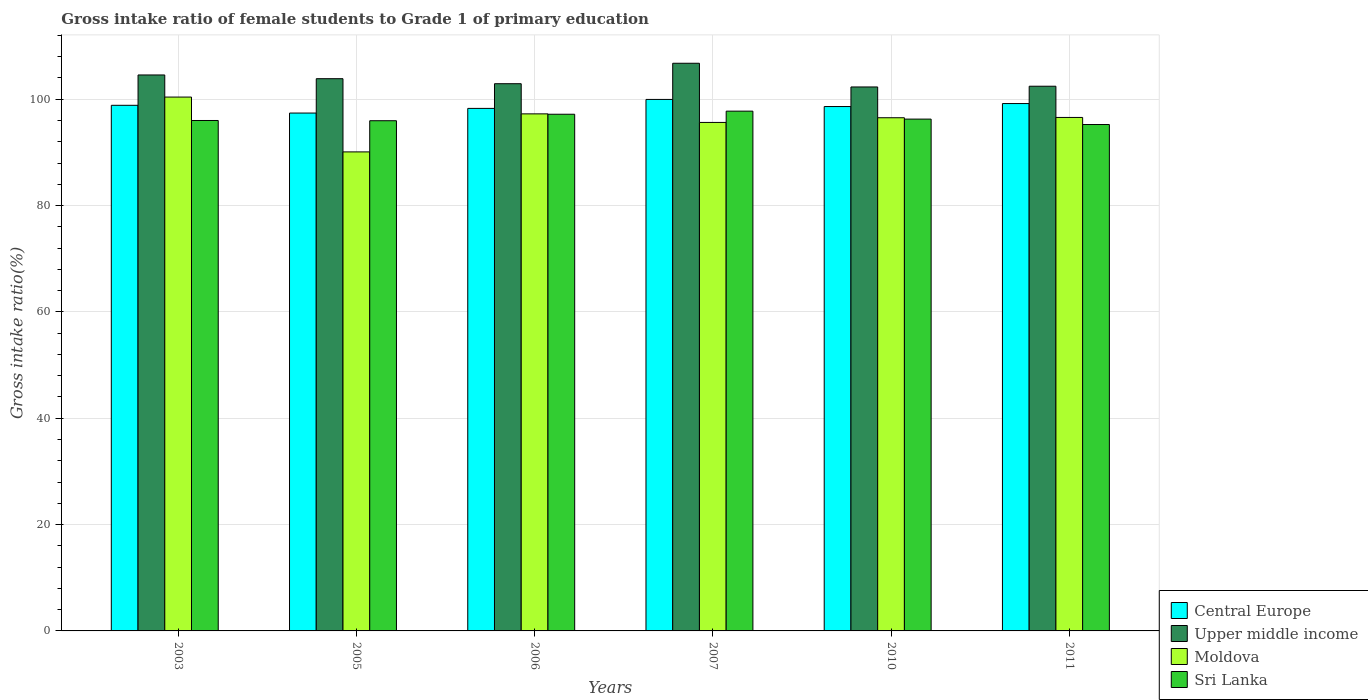Are the number of bars per tick equal to the number of legend labels?
Ensure brevity in your answer.  Yes. Are the number of bars on each tick of the X-axis equal?
Your answer should be very brief. Yes. How many bars are there on the 3rd tick from the left?
Give a very brief answer. 4. What is the label of the 2nd group of bars from the left?
Provide a succinct answer. 2005. What is the gross intake ratio in Sri Lanka in 2007?
Offer a very short reply. 97.76. Across all years, what is the maximum gross intake ratio in Central Europe?
Give a very brief answer. 99.97. Across all years, what is the minimum gross intake ratio in Upper middle income?
Offer a very short reply. 102.31. What is the total gross intake ratio in Sri Lanka in the graph?
Give a very brief answer. 578.43. What is the difference between the gross intake ratio in Upper middle income in 2005 and that in 2011?
Offer a terse response. 1.42. What is the difference between the gross intake ratio in Moldova in 2007 and the gross intake ratio in Upper middle income in 2005?
Make the answer very short. -8.22. What is the average gross intake ratio in Sri Lanka per year?
Give a very brief answer. 96.41. In the year 2007, what is the difference between the gross intake ratio in Upper middle income and gross intake ratio in Sri Lanka?
Keep it short and to the point. 9.01. In how many years, is the gross intake ratio in Moldova greater than 48 %?
Keep it short and to the point. 6. What is the ratio of the gross intake ratio in Moldova in 2005 to that in 2007?
Keep it short and to the point. 0.94. What is the difference between the highest and the second highest gross intake ratio in Upper middle income?
Offer a terse response. 2.2. What is the difference between the highest and the lowest gross intake ratio in Central Europe?
Give a very brief answer. 2.56. In how many years, is the gross intake ratio in Moldova greater than the average gross intake ratio in Moldova taken over all years?
Keep it short and to the point. 4. Is the sum of the gross intake ratio in Sri Lanka in 2005 and 2007 greater than the maximum gross intake ratio in Moldova across all years?
Keep it short and to the point. Yes. What does the 3rd bar from the left in 2006 represents?
Your answer should be compact. Moldova. What does the 1st bar from the right in 2007 represents?
Ensure brevity in your answer.  Sri Lanka. Is it the case that in every year, the sum of the gross intake ratio in Central Europe and gross intake ratio in Upper middle income is greater than the gross intake ratio in Sri Lanka?
Your response must be concise. Yes. How many bars are there?
Keep it short and to the point. 24. What is the difference between two consecutive major ticks on the Y-axis?
Give a very brief answer. 20. Where does the legend appear in the graph?
Provide a succinct answer. Bottom right. How many legend labels are there?
Your response must be concise. 4. What is the title of the graph?
Ensure brevity in your answer.  Gross intake ratio of female students to Grade 1 of primary education. Does "Sint Maarten (Dutch part)" appear as one of the legend labels in the graph?
Make the answer very short. No. What is the label or title of the Y-axis?
Provide a short and direct response. Gross intake ratio(%). What is the Gross intake ratio(%) in Central Europe in 2003?
Ensure brevity in your answer.  98.86. What is the Gross intake ratio(%) in Upper middle income in 2003?
Your answer should be compact. 104.57. What is the Gross intake ratio(%) of Moldova in 2003?
Ensure brevity in your answer.  100.41. What is the Gross intake ratio(%) in Sri Lanka in 2003?
Provide a succinct answer. 96.01. What is the Gross intake ratio(%) of Central Europe in 2005?
Your answer should be very brief. 97.4. What is the Gross intake ratio(%) in Upper middle income in 2005?
Your response must be concise. 103.87. What is the Gross intake ratio(%) in Moldova in 2005?
Ensure brevity in your answer.  90.1. What is the Gross intake ratio(%) of Sri Lanka in 2005?
Keep it short and to the point. 95.96. What is the Gross intake ratio(%) of Central Europe in 2006?
Provide a short and direct response. 98.28. What is the Gross intake ratio(%) in Upper middle income in 2006?
Your response must be concise. 102.93. What is the Gross intake ratio(%) in Moldova in 2006?
Offer a terse response. 97.25. What is the Gross intake ratio(%) in Sri Lanka in 2006?
Offer a very short reply. 97.18. What is the Gross intake ratio(%) of Central Europe in 2007?
Your answer should be compact. 99.97. What is the Gross intake ratio(%) in Upper middle income in 2007?
Give a very brief answer. 106.77. What is the Gross intake ratio(%) of Moldova in 2007?
Give a very brief answer. 95.64. What is the Gross intake ratio(%) of Sri Lanka in 2007?
Ensure brevity in your answer.  97.76. What is the Gross intake ratio(%) of Central Europe in 2010?
Give a very brief answer. 98.63. What is the Gross intake ratio(%) in Upper middle income in 2010?
Give a very brief answer. 102.31. What is the Gross intake ratio(%) in Moldova in 2010?
Your answer should be compact. 96.52. What is the Gross intake ratio(%) of Sri Lanka in 2010?
Keep it short and to the point. 96.27. What is the Gross intake ratio(%) in Central Europe in 2011?
Provide a short and direct response. 99.19. What is the Gross intake ratio(%) of Upper middle income in 2011?
Your answer should be compact. 102.45. What is the Gross intake ratio(%) in Moldova in 2011?
Give a very brief answer. 96.58. What is the Gross intake ratio(%) of Sri Lanka in 2011?
Offer a terse response. 95.25. Across all years, what is the maximum Gross intake ratio(%) of Central Europe?
Ensure brevity in your answer.  99.97. Across all years, what is the maximum Gross intake ratio(%) in Upper middle income?
Make the answer very short. 106.77. Across all years, what is the maximum Gross intake ratio(%) in Moldova?
Offer a very short reply. 100.41. Across all years, what is the maximum Gross intake ratio(%) in Sri Lanka?
Provide a succinct answer. 97.76. Across all years, what is the minimum Gross intake ratio(%) in Central Europe?
Offer a terse response. 97.4. Across all years, what is the minimum Gross intake ratio(%) in Upper middle income?
Offer a terse response. 102.31. Across all years, what is the minimum Gross intake ratio(%) of Moldova?
Your answer should be very brief. 90.1. Across all years, what is the minimum Gross intake ratio(%) in Sri Lanka?
Provide a succinct answer. 95.25. What is the total Gross intake ratio(%) of Central Europe in the graph?
Give a very brief answer. 592.34. What is the total Gross intake ratio(%) of Upper middle income in the graph?
Ensure brevity in your answer.  622.9. What is the total Gross intake ratio(%) in Moldova in the graph?
Your answer should be very brief. 576.51. What is the total Gross intake ratio(%) of Sri Lanka in the graph?
Your answer should be compact. 578.43. What is the difference between the Gross intake ratio(%) of Central Europe in 2003 and that in 2005?
Give a very brief answer. 1.46. What is the difference between the Gross intake ratio(%) of Upper middle income in 2003 and that in 2005?
Give a very brief answer. 0.7. What is the difference between the Gross intake ratio(%) of Moldova in 2003 and that in 2005?
Provide a short and direct response. 10.31. What is the difference between the Gross intake ratio(%) in Sri Lanka in 2003 and that in 2005?
Offer a terse response. 0.04. What is the difference between the Gross intake ratio(%) of Central Europe in 2003 and that in 2006?
Provide a succinct answer. 0.58. What is the difference between the Gross intake ratio(%) of Upper middle income in 2003 and that in 2006?
Provide a short and direct response. 1.64. What is the difference between the Gross intake ratio(%) of Moldova in 2003 and that in 2006?
Your answer should be very brief. 3.16. What is the difference between the Gross intake ratio(%) of Sri Lanka in 2003 and that in 2006?
Provide a short and direct response. -1.18. What is the difference between the Gross intake ratio(%) of Central Europe in 2003 and that in 2007?
Give a very brief answer. -1.1. What is the difference between the Gross intake ratio(%) of Upper middle income in 2003 and that in 2007?
Provide a short and direct response. -2.2. What is the difference between the Gross intake ratio(%) in Moldova in 2003 and that in 2007?
Provide a succinct answer. 4.77. What is the difference between the Gross intake ratio(%) of Sri Lanka in 2003 and that in 2007?
Your answer should be compact. -1.76. What is the difference between the Gross intake ratio(%) of Central Europe in 2003 and that in 2010?
Provide a succinct answer. 0.23. What is the difference between the Gross intake ratio(%) of Upper middle income in 2003 and that in 2010?
Ensure brevity in your answer.  2.26. What is the difference between the Gross intake ratio(%) of Moldova in 2003 and that in 2010?
Your answer should be compact. 3.89. What is the difference between the Gross intake ratio(%) of Sri Lanka in 2003 and that in 2010?
Provide a succinct answer. -0.26. What is the difference between the Gross intake ratio(%) in Central Europe in 2003 and that in 2011?
Your response must be concise. -0.33. What is the difference between the Gross intake ratio(%) in Upper middle income in 2003 and that in 2011?
Provide a short and direct response. 2.12. What is the difference between the Gross intake ratio(%) of Moldova in 2003 and that in 2011?
Make the answer very short. 3.83. What is the difference between the Gross intake ratio(%) in Sri Lanka in 2003 and that in 2011?
Make the answer very short. 0.76. What is the difference between the Gross intake ratio(%) in Central Europe in 2005 and that in 2006?
Your answer should be compact. -0.88. What is the difference between the Gross intake ratio(%) of Upper middle income in 2005 and that in 2006?
Provide a short and direct response. 0.94. What is the difference between the Gross intake ratio(%) of Moldova in 2005 and that in 2006?
Your answer should be very brief. -7.15. What is the difference between the Gross intake ratio(%) in Sri Lanka in 2005 and that in 2006?
Your response must be concise. -1.22. What is the difference between the Gross intake ratio(%) in Central Europe in 2005 and that in 2007?
Your answer should be compact. -2.56. What is the difference between the Gross intake ratio(%) of Upper middle income in 2005 and that in 2007?
Keep it short and to the point. -2.9. What is the difference between the Gross intake ratio(%) of Moldova in 2005 and that in 2007?
Your answer should be very brief. -5.54. What is the difference between the Gross intake ratio(%) of Sri Lanka in 2005 and that in 2007?
Offer a very short reply. -1.8. What is the difference between the Gross intake ratio(%) of Central Europe in 2005 and that in 2010?
Your answer should be compact. -1.23. What is the difference between the Gross intake ratio(%) of Upper middle income in 2005 and that in 2010?
Offer a very short reply. 1.55. What is the difference between the Gross intake ratio(%) of Moldova in 2005 and that in 2010?
Provide a short and direct response. -6.42. What is the difference between the Gross intake ratio(%) in Sri Lanka in 2005 and that in 2010?
Provide a short and direct response. -0.31. What is the difference between the Gross intake ratio(%) in Central Europe in 2005 and that in 2011?
Offer a terse response. -1.79. What is the difference between the Gross intake ratio(%) in Upper middle income in 2005 and that in 2011?
Provide a short and direct response. 1.42. What is the difference between the Gross intake ratio(%) of Moldova in 2005 and that in 2011?
Your answer should be compact. -6.48. What is the difference between the Gross intake ratio(%) in Sri Lanka in 2005 and that in 2011?
Your response must be concise. 0.71. What is the difference between the Gross intake ratio(%) in Central Europe in 2006 and that in 2007?
Give a very brief answer. -1.69. What is the difference between the Gross intake ratio(%) in Upper middle income in 2006 and that in 2007?
Provide a succinct answer. -3.85. What is the difference between the Gross intake ratio(%) in Moldova in 2006 and that in 2007?
Keep it short and to the point. 1.61. What is the difference between the Gross intake ratio(%) of Sri Lanka in 2006 and that in 2007?
Your answer should be very brief. -0.58. What is the difference between the Gross intake ratio(%) in Central Europe in 2006 and that in 2010?
Your answer should be compact. -0.35. What is the difference between the Gross intake ratio(%) in Upper middle income in 2006 and that in 2010?
Make the answer very short. 0.61. What is the difference between the Gross intake ratio(%) in Moldova in 2006 and that in 2010?
Provide a succinct answer. 0.73. What is the difference between the Gross intake ratio(%) in Sri Lanka in 2006 and that in 2010?
Ensure brevity in your answer.  0.91. What is the difference between the Gross intake ratio(%) in Central Europe in 2006 and that in 2011?
Offer a very short reply. -0.91. What is the difference between the Gross intake ratio(%) in Upper middle income in 2006 and that in 2011?
Keep it short and to the point. 0.47. What is the difference between the Gross intake ratio(%) in Moldova in 2006 and that in 2011?
Keep it short and to the point. 0.67. What is the difference between the Gross intake ratio(%) of Sri Lanka in 2006 and that in 2011?
Make the answer very short. 1.93. What is the difference between the Gross intake ratio(%) in Central Europe in 2007 and that in 2010?
Your answer should be compact. 1.34. What is the difference between the Gross intake ratio(%) in Upper middle income in 2007 and that in 2010?
Your answer should be very brief. 4.46. What is the difference between the Gross intake ratio(%) of Moldova in 2007 and that in 2010?
Ensure brevity in your answer.  -0.88. What is the difference between the Gross intake ratio(%) in Sri Lanka in 2007 and that in 2010?
Provide a succinct answer. 1.49. What is the difference between the Gross intake ratio(%) in Central Europe in 2007 and that in 2011?
Provide a succinct answer. 0.78. What is the difference between the Gross intake ratio(%) of Upper middle income in 2007 and that in 2011?
Provide a succinct answer. 4.32. What is the difference between the Gross intake ratio(%) of Moldova in 2007 and that in 2011?
Offer a very short reply. -0.94. What is the difference between the Gross intake ratio(%) in Sri Lanka in 2007 and that in 2011?
Your response must be concise. 2.52. What is the difference between the Gross intake ratio(%) in Central Europe in 2010 and that in 2011?
Provide a short and direct response. -0.56. What is the difference between the Gross intake ratio(%) in Upper middle income in 2010 and that in 2011?
Provide a short and direct response. -0.14. What is the difference between the Gross intake ratio(%) in Moldova in 2010 and that in 2011?
Give a very brief answer. -0.06. What is the difference between the Gross intake ratio(%) in Sri Lanka in 2010 and that in 2011?
Your answer should be compact. 1.02. What is the difference between the Gross intake ratio(%) of Central Europe in 2003 and the Gross intake ratio(%) of Upper middle income in 2005?
Offer a terse response. -5. What is the difference between the Gross intake ratio(%) in Central Europe in 2003 and the Gross intake ratio(%) in Moldova in 2005?
Offer a terse response. 8.76. What is the difference between the Gross intake ratio(%) of Central Europe in 2003 and the Gross intake ratio(%) of Sri Lanka in 2005?
Provide a short and direct response. 2.9. What is the difference between the Gross intake ratio(%) in Upper middle income in 2003 and the Gross intake ratio(%) in Moldova in 2005?
Keep it short and to the point. 14.47. What is the difference between the Gross intake ratio(%) of Upper middle income in 2003 and the Gross intake ratio(%) of Sri Lanka in 2005?
Provide a succinct answer. 8.61. What is the difference between the Gross intake ratio(%) in Moldova in 2003 and the Gross intake ratio(%) in Sri Lanka in 2005?
Offer a very short reply. 4.45. What is the difference between the Gross intake ratio(%) in Central Europe in 2003 and the Gross intake ratio(%) in Upper middle income in 2006?
Make the answer very short. -4.06. What is the difference between the Gross intake ratio(%) of Central Europe in 2003 and the Gross intake ratio(%) of Moldova in 2006?
Ensure brevity in your answer.  1.61. What is the difference between the Gross intake ratio(%) in Central Europe in 2003 and the Gross intake ratio(%) in Sri Lanka in 2006?
Provide a succinct answer. 1.68. What is the difference between the Gross intake ratio(%) of Upper middle income in 2003 and the Gross intake ratio(%) of Moldova in 2006?
Give a very brief answer. 7.32. What is the difference between the Gross intake ratio(%) of Upper middle income in 2003 and the Gross intake ratio(%) of Sri Lanka in 2006?
Keep it short and to the point. 7.39. What is the difference between the Gross intake ratio(%) of Moldova in 2003 and the Gross intake ratio(%) of Sri Lanka in 2006?
Ensure brevity in your answer.  3.23. What is the difference between the Gross intake ratio(%) in Central Europe in 2003 and the Gross intake ratio(%) in Upper middle income in 2007?
Keep it short and to the point. -7.91. What is the difference between the Gross intake ratio(%) in Central Europe in 2003 and the Gross intake ratio(%) in Moldova in 2007?
Your response must be concise. 3.22. What is the difference between the Gross intake ratio(%) of Central Europe in 2003 and the Gross intake ratio(%) of Sri Lanka in 2007?
Give a very brief answer. 1.1. What is the difference between the Gross intake ratio(%) in Upper middle income in 2003 and the Gross intake ratio(%) in Moldova in 2007?
Offer a terse response. 8.93. What is the difference between the Gross intake ratio(%) in Upper middle income in 2003 and the Gross intake ratio(%) in Sri Lanka in 2007?
Keep it short and to the point. 6.81. What is the difference between the Gross intake ratio(%) in Moldova in 2003 and the Gross intake ratio(%) in Sri Lanka in 2007?
Offer a terse response. 2.65. What is the difference between the Gross intake ratio(%) of Central Europe in 2003 and the Gross intake ratio(%) of Upper middle income in 2010?
Provide a short and direct response. -3.45. What is the difference between the Gross intake ratio(%) in Central Europe in 2003 and the Gross intake ratio(%) in Moldova in 2010?
Your response must be concise. 2.34. What is the difference between the Gross intake ratio(%) of Central Europe in 2003 and the Gross intake ratio(%) of Sri Lanka in 2010?
Keep it short and to the point. 2.59. What is the difference between the Gross intake ratio(%) in Upper middle income in 2003 and the Gross intake ratio(%) in Moldova in 2010?
Offer a very short reply. 8.05. What is the difference between the Gross intake ratio(%) of Upper middle income in 2003 and the Gross intake ratio(%) of Sri Lanka in 2010?
Offer a terse response. 8.3. What is the difference between the Gross intake ratio(%) of Moldova in 2003 and the Gross intake ratio(%) of Sri Lanka in 2010?
Provide a succinct answer. 4.14. What is the difference between the Gross intake ratio(%) in Central Europe in 2003 and the Gross intake ratio(%) in Upper middle income in 2011?
Offer a very short reply. -3.59. What is the difference between the Gross intake ratio(%) in Central Europe in 2003 and the Gross intake ratio(%) in Moldova in 2011?
Your answer should be compact. 2.28. What is the difference between the Gross intake ratio(%) of Central Europe in 2003 and the Gross intake ratio(%) of Sri Lanka in 2011?
Your answer should be compact. 3.62. What is the difference between the Gross intake ratio(%) of Upper middle income in 2003 and the Gross intake ratio(%) of Moldova in 2011?
Your answer should be very brief. 7.99. What is the difference between the Gross intake ratio(%) of Upper middle income in 2003 and the Gross intake ratio(%) of Sri Lanka in 2011?
Ensure brevity in your answer.  9.32. What is the difference between the Gross intake ratio(%) in Moldova in 2003 and the Gross intake ratio(%) in Sri Lanka in 2011?
Your response must be concise. 5.16. What is the difference between the Gross intake ratio(%) of Central Europe in 2005 and the Gross intake ratio(%) of Upper middle income in 2006?
Provide a succinct answer. -5.52. What is the difference between the Gross intake ratio(%) of Central Europe in 2005 and the Gross intake ratio(%) of Moldova in 2006?
Your answer should be compact. 0.15. What is the difference between the Gross intake ratio(%) of Central Europe in 2005 and the Gross intake ratio(%) of Sri Lanka in 2006?
Your answer should be compact. 0.22. What is the difference between the Gross intake ratio(%) in Upper middle income in 2005 and the Gross intake ratio(%) in Moldova in 2006?
Give a very brief answer. 6.62. What is the difference between the Gross intake ratio(%) in Upper middle income in 2005 and the Gross intake ratio(%) in Sri Lanka in 2006?
Your answer should be compact. 6.69. What is the difference between the Gross intake ratio(%) in Moldova in 2005 and the Gross intake ratio(%) in Sri Lanka in 2006?
Your answer should be compact. -7.08. What is the difference between the Gross intake ratio(%) of Central Europe in 2005 and the Gross intake ratio(%) of Upper middle income in 2007?
Your response must be concise. -9.37. What is the difference between the Gross intake ratio(%) in Central Europe in 2005 and the Gross intake ratio(%) in Moldova in 2007?
Your answer should be very brief. 1.76. What is the difference between the Gross intake ratio(%) of Central Europe in 2005 and the Gross intake ratio(%) of Sri Lanka in 2007?
Provide a short and direct response. -0.36. What is the difference between the Gross intake ratio(%) in Upper middle income in 2005 and the Gross intake ratio(%) in Moldova in 2007?
Offer a very short reply. 8.22. What is the difference between the Gross intake ratio(%) in Upper middle income in 2005 and the Gross intake ratio(%) in Sri Lanka in 2007?
Your response must be concise. 6.1. What is the difference between the Gross intake ratio(%) in Moldova in 2005 and the Gross intake ratio(%) in Sri Lanka in 2007?
Give a very brief answer. -7.66. What is the difference between the Gross intake ratio(%) in Central Europe in 2005 and the Gross intake ratio(%) in Upper middle income in 2010?
Offer a very short reply. -4.91. What is the difference between the Gross intake ratio(%) of Central Europe in 2005 and the Gross intake ratio(%) of Moldova in 2010?
Your answer should be compact. 0.88. What is the difference between the Gross intake ratio(%) in Central Europe in 2005 and the Gross intake ratio(%) in Sri Lanka in 2010?
Provide a succinct answer. 1.14. What is the difference between the Gross intake ratio(%) in Upper middle income in 2005 and the Gross intake ratio(%) in Moldova in 2010?
Offer a terse response. 7.34. What is the difference between the Gross intake ratio(%) of Upper middle income in 2005 and the Gross intake ratio(%) of Sri Lanka in 2010?
Your answer should be very brief. 7.6. What is the difference between the Gross intake ratio(%) of Moldova in 2005 and the Gross intake ratio(%) of Sri Lanka in 2010?
Keep it short and to the point. -6.17. What is the difference between the Gross intake ratio(%) in Central Europe in 2005 and the Gross intake ratio(%) in Upper middle income in 2011?
Ensure brevity in your answer.  -5.05. What is the difference between the Gross intake ratio(%) of Central Europe in 2005 and the Gross intake ratio(%) of Moldova in 2011?
Your answer should be very brief. 0.82. What is the difference between the Gross intake ratio(%) in Central Europe in 2005 and the Gross intake ratio(%) in Sri Lanka in 2011?
Give a very brief answer. 2.16. What is the difference between the Gross intake ratio(%) of Upper middle income in 2005 and the Gross intake ratio(%) of Moldova in 2011?
Your answer should be very brief. 7.29. What is the difference between the Gross intake ratio(%) of Upper middle income in 2005 and the Gross intake ratio(%) of Sri Lanka in 2011?
Ensure brevity in your answer.  8.62. What is the difference between the Gross intake ratio(%) in Moldova in 2005 and the Gross intake ratio(%) in Sri Lanka in 2011?
Offer a terse response. -5.15. What is the difference between the Gross intake ratio(%) of Central Europe in 2006 and the Gross intake ratio(%) of Upper middle income in 2007?
Your response must be concise. -8.49. What is the difference between the Gross intake ratio(%) of Central Europe in 2006 and the Gross intake ratio(%) of Moldova in 2007?
Provide a short and direct response. 2.64. What is the difference between the Gross intake ratio(%) of Central Europe in 2006 and the Gross intake ratio(%) of Sri Lanka in 2007?
Your answer should be very brief. 0.52. What is the difference between the Gross intake ratio(%) in Upper middle income in 2006 and the Gross intake ratio(%) in Moldova in 2007?
Your answer should be very brief. 7.28. What is the difference between the Gross intake ratio(%) of Upper middle income in 2006 and the Gross intake ratio(%) of Sri Lanka in 2007?
Offer a terse response. 5.16. What is the difference between the Gross intake ratio(%) in Moldova in 2006 and the Gross intake ratio(%) in Sri Lanka in 2007?
Your response must be concise. -0.51. What is the difference between the Gross intake ratio(%) of Central Europe in 2006 and the Gross intake ratio(%) of Upper middle income in 2010?
Your answer should be compact. -4.03. What is the difference between the Gross intake ratio(%) of Central Europe in 2006 and the Gross intake ratio(%) of Moldova in 2010?
Keep it short and to the point. 1.76. What is the difference between the Gross intake ratio(%) in Central Europe in 2006 and the Gross intake ratio(%) in Sri Lanka in 2010?
Provide a short and direct response. 2.01. What is the difference between the Gross intake ratio(%) of Upper middle income in 2006 and the Gross intake ratio(%) of Moldova in 2010?
Ensure brevity in your answer.  6.4. What is the difference between the Gross intake ratio(%) of Upper middle income in 2006 and the Gross intake ratio(%) of Sri Lanka in 2010?
Your answer should be compact. 6.66. What is the difference between the Gross intake ratio(%) in Moldova in 2006 and the Gross intake ratio(%) in Sri Lanka in 2010?
Offer a very short reply. 0.98. What is the difference between the Gross intake ratio(%) of Central Europe in 2006 and the Gross intake ratio(%) of Upper middle income in 2011?
Your answer should be compact. -4.17. What is the difference between the Gross intake ratio(%) of Central Europe in 2006 and the Gross intake ratio(%) of Moldova in 2011?
Ensure brevity in your answer.  1.7. What is the difference between the Gross intake ratio(%) of Central Europe in 2006 and the Gross intake ratio(%) of Sri Lanka in 2011?
Offer a terse response. 3.03. What is the difference between the Gross intake ratio(%) in Upper middle income in 2006 and the Gross intake ratio(%) in Moldova in 2011?
Provide a short and direct response. 6.34. What is the difference between the Gross intake ratio(%) in Upper middle income in 2006 and the Gross intake ratio(%) in Sri Lanka in 2011?
Offer a terse response. 7.68. What is the difference between the Gross intake ratio(%) in Moldova in 2006 and the Gross intake ratio(%) in Sri Lanka in 2011?
Offer a very short reply. 2.01. What is the difference between the Gross intake ratio(%) in Central Europe in 2007 and the Gross intake ratio(%) in Upper middle income in 2010?
Provide a short and direct response. -2.35. What is the difference between the Gross intake ratio(%) of Central Europe in 2007 and the Gross intake ratio(%) of Moldova in 2010?
Make the answer very short. 3.44. What is the difference between the Gross intake ratio(%) of Central Europe in 2007 and the Gross intake ratio(%) of Sri Lanka in 2010?
Give a very brief answer. 3.7. What is the difference between the Gross intake ratio(%) in Upper middle income in 2007 and the Gross intake ratio(%) in Moldova in 2010?
Keep it short and to the point. 10.25. What is the difference between the Gross intake ratio(%) of Upper middle income in 2007 and the Gross intake ratio(%) of Sri Lanka in 2010?
Your answer should be compact. 10.5. What is the difference between the Gross intake ratio(%) of Moldova in 2007 and the Gross intake ratio(%) of Sri Lanka in 2010?
Offer a terse response. -0.63. What is the difference between the Gross intake ratio(%) of Central Europe in 2007 and the Gross intake ratio(%) of Upper middle income in 2011?
Ensure brevity in your answer.  -2.48. What is the difference between the Gross intake ratio(%) of Central Europe in 2007 and the Gross intake ratio(%) of Moldova in 2011?
Provide a succinct answer. 3.39. What is the difference between the Gross intake ratio(%) in Central Europe in 2007 and the Gross intake ratio(%) in Sri Lanka in 2011?
Your response must be concise. 4.72. What is the difference between the Gross intake ratio(%) in Upper middle income in 2007 and the Gross intake ratio(%) in Moldova in 2011?
Offer a terse response. 10.19. What is the difference between the Gross intake ratio(%) in Upper middle income in 2007 and the Gross intake ratio(%) in Sri Lanka in 2011?
Provide a succinct answer. 11.52. What is the difference between the Gross intake ratio(%) in Moldova in 2007 and the Gross intake ratio(%) in Sri Lanka in 2011?
Give a very brief answer. 0.4. What is the difference between the Gross intake ratio(%) of Central Europe in 2010 and the Gross intake ratio(%) of Upper middle income in 2011?
Provide a short and direct response. -3.82. What is the difference between the Gross intake ratio(%) in Central Europe in 2010 and the Gross intake ratio(%) in Moldova in 2011?
Offer a terse response. 2.05. What is the difference between the Gross intake ratio(%) of Central Europe in 2010 and the Gross intake ratio(%) of Sri Lanka in 2011?
Give a very brief answer. 3.38. What is the difference between the Gross intake ratio(%) of Upper middle income in 2010 and the Gross intake ratio(%) of Moldova in 2011?
Your answer should be compact. 5.73. What is the difference between the Gross intake ratio(%) of Upper middle income in 2010 and the Gross intake ratio(%) of Sri Lanka in 2011?
Ensure brevity in your answer.  7.07. What is the difference between the Gross intake ratio(%) of Moldova in 2010 and the Gross intake ratio(%) of Sri Lanka in 2011?
Keep it short and to the point. 1.28. What is the average Gross intake ratio(%) of Central Europe per year?
Offer a terse response. 98.72. What is the average Gross intake ratio(%) of Upper middle income per year?
Your answer should be very brief. 103.82. What is the average Gross intake ratio(%) of Moldova per year?
Your response must be concise. 96.09. What is the average Gross intake ratio(%) of Sri Lanka per year?
Give a very brief answer. 96.41. In the year 2003, what is the difference between the Gross intake ratio(%) of Central Europe and Gross intake ratio(%) of Upper middle income?
Offer a very short reply. -5.7. In the year 2003, what is the difference between the Gross intake ratio(%) in Central Europe and Gross intake ratio(%) in Moldova?
Offer a terse response. -1.55. In the year 2003, what is the difference between the Gross intake ratio(%) in Central Europe and Gross intake ratio(%) in Sri Lanka?
Keep it short and to the point. 2.86. In the year 2003, what is the difference between the Gross intake ratio(%) of Upper middle income and Gross intake ratio(%) of Moldova?
Provide a succinct answer. 4.16. In the year 2003, what is the difference between the Gross intake ratio(%) of Upper middle income and Gross intake ratio(%) of Sri Lanka?
Your answer should be very brief. 8.56. In the year 2003, what is the difference between the Gross intake ratio(%) of Moldova and Gross intake ratio(%) of Sri Lanka?
Your answer should be very brief. 4.41. In the year 2005, what is the difference between the Gross intake ratio(%) in Central Europe and Gross intake ratio(%) in Upper middle income?
Make the answer very short. -6.46. In the year 2005, what is the difference between the Gross intake ratio(%) of Central Europe and Gross intake ratio(%) of Moldova?
Your response must be concise. 7.31. In the year 2005, what is the difference between the Gross intake ratio(%) in Central Europe and Gross intake ratio(%) in Sri Lanka?
Give a very brief answer. 1.44. In the year 2005, what is the difference between the Gross intake ratio(%) of Upper middle income and Gross intake ratio(%) of Moldova?
Offer a very short reply. 13.77. In the year 2005, what is the difference between the Gross intake ratio(%) of Upper middle income and Gross intake ratio(%) of Sri Lanka?
Give a very brief answer. 7.91. In the year 2005, what is the difference between the Gross intake ratio(%) of Moldova and Gross intake ratio(%) of Sri Lanka?
Your answer should be compact. -5.86. In the year 2006, what is the difference between the Gross intake ratio(%) of Central Europe and Gross intake ratio(%) of Upper middle income?
Provide a succinct answer. -4.65. In the year 2006, what is the difference between the Gross intake ratio(%) in Central Europe and Gross intake ratio(%) in Moldova?
Ensure brevity in your answer.  1.03. In the year 2006, what is the difference between the Gross intake ratio(%) in Central Europe and Gross intake ratio(%) in Sri Lanka?
Your response must be concise. 1.1. In the year 2006, what is the difference between the Gross intake ratio(%) in Upper middle income and Gross intake ratio(%) in Moldova?
Your answer should be compact. 5.67. In the year 2006, what is the difference between the Gross intake ratio(%) in Upper middle income and Gross intake ratio(%) in Sri Lanka?
Keep it short and to the point. 5.74. In the year 2006, what is the difference between the Gross intake ratio(%) in Moldova and Gross intake ratio(%) in Sri Lanka?
Your answer should be compact. 0.07. In the year 2007, what is the difference between the Gross intake ratio(%) of Central Europe and Gross intake ratio(%) of Upper middle income?
Keep it short and to the point. -6.8. In the year 2007, what is the difference between the Gross intake ratio(%) of Central Europe and Gross intake ratio(%) of Moldova?
Make the answer very short. 4.32. In the year 2007, what is the difference between the Gross intake ratio(%) in Central Europe and Gross intake ratio(%) in Sri Lanka?
Your response must be concise. 2.2. In the year 2007, what is the difference between the Gross intake ratio(%) in Upper middle income and Gross intake ratio(%) in Moldova?
Your response must be concise. 11.13. In the year 2007, what is the difference between the Gross intake ratio(%) of Upper middle income and Gross intake ratio(%) of Sri Lanka?
Your response must be concise. 9.01. In the year 2007, what is the difference between the Gross intake ratio(%) in Moldova and Gross intake ratio(%) in Sri Lanka?
Ensure brevity in your answer.  -2.12. In the year 2010, what is the difference between the Gross intake ratio(%) in Central Europe and Gross intake ratio(%) in Upper middle income?
Your answer should be very brief. -3.68. In the year 2010, what is the difference between the Gross intake ratio(%) of Central Europe and Gross intake ratio(%) of Moldova?
Your response must be concise. 2.11. In the year 2010, what is the difference between the Gross intake ratio(%) in Central Europe and Gross intake ratio(%) in Sri Lanka?
Provide a short and direct response. 2.36. In the year 2010, what is the difference between the Gross intake ratio(%) of Upper middle income and Gross intake ratio(%) of Moldova?
Provide a short and direct response. 5.79. In the year 2010, what is the difference between the Gross intake ratio(%) in Upper middle income and Gross intake ratio(%) in Sri Lanka?
Your answer should be very brief. 6.04. In the year 2010, what is the difference between the Gross intake ratio(%) in Moldova and Gross intake ratio(%) in Sri Lanka?
Keep it short and to the point. 0.25. In the year 2011, what is the difference between the Gross intake ratio(%) in Central Europe and Gross intake ratio(%) in Upper middle income?
Offer a very short reply. -3.26. In the year 2011, what is the difference between the Gross intake ratio(%) in Central Europe and Gross intake ratio(%) in Moldova?
Ensure brevity in your answer.  2.61. In the year 2011, what is the difference between the Gross intake ratio(%) of Central Europe and Gross intake ratio(%) of Sri Lanka?
Provide a short and direct response. 3.94. In the year 2011, what is the difference between the Gross intake ratio(%) of Upper middle income and Gross intake ratio(%) of Moldova?
Provide a succinct answer. 5.87. In the year 2011, what is the difference between the Gross intake ratio(%) in Upper middle income and Gross intake ratio(%) in Sri Lanka?
Your answer should be compact. 7.2. In the year 2011, what is the difference between the Gross intake ratio(%) in Moldova and Gross intake ratio(%) in Sri Lanka?
Provide a succinct answer. 1.33. What is the ratio of the Gross intake ratio(%) of Central Europe in 2003 to that in 2005?
Offer a terse response. 1.01. What is the ratio of the Gross intake ratio(%) in Moldova in 2003 to that in 2005?
Offer a terse response. 1.11. What is the ratio of the Gross intake ratio(%) of Central Europe in 2003 to that in 2006?
Your answer should be compact. 1.01. What is the ratio of the Gross intake ratio(%) of Moldova in 2003 to that in 2006?
Offer a terse response. 1.03. What is the ratio of the Gross intake ratio(%) of Sri Lanka in 2003 to that in 2006?
Your answer should be very brief. 0.99. What is the ratio of the Gross intake ratio(%) of Upper middle income in 2003 to that in 2007?
Provide a short and direct response. 0.98. What is the ratio of the Gross intake ratio(%) of Moldova in 2003 to that in 2007?
Provide a succinct answer. 1.05. What is the ratio of the Gross intake ratio(%) in Central Europe in 2003 to that in 2010?
Ensure brevity in your answer.  1. What is the ratio of the Gross intake ratio(%) of Moldova in 2003 to that in 2010?
Keep it short and to the point. 1.04. What is the ratio of the Gross intake ratio(%) in Central Europe in 2003 to that in 2011?
Make the answer very short. 1. What is the ratio of the Gross intake ratio(%) in Upper middle income in 2003 to that in 2011?
Your response must be concise. 1.02. What is the ratio of the Gross intake ratio(%) of Moldova in 2003 to that in 2011?
Ensure brevity in your answer.  1.04. What is the ratio of the Gross intake ratio(%) in Sri Lanka in 2003 to that in 2011?
Give a very brief answer. 1.01. What is the ratio of the Gross intake ratio(%) in Upper middle income in 2005 to that in 2006?
Your response must be concise. 1.01. What is the ratio of the Gross intake ratio(%) in Moldova in 2005 to that in 2006?
Provide a succinct answer. 0.93. What is the ratio of the Gross intake ratio(%) in Sri Lanka in 2005 to that in 2006?
Keep it short and to the point. 0.99. What is the ratio of the Gross intake ratio(%) in Central Europe in 2005 to that in 2007?
Offer a very short reply. 0.97. What is the ratio of the Gross intake ratio(%) of Upper middle income in 2005 to that in 2007?
Offer a terse response. 0.97. What is the ratio of the Gross intake ratio(%) in Moldova in 2005 to that in 2007?
Your answer should be compact. 0.94. What is the ratio of the Gross intake ratio(%) of Sri Lanka in 2005 to that in 2007?
Provide a succinct answer. 0.98. What is the ratio of the Gross intake ratio(%) in Central Europe in 2005 to that in 2010?
Give a very brief answer. 0.99. What is the ratio of the Gross intake ratio(%) of Upper middle income in 2005 to that in 2010?
Offer a very short reply. 1.02. What is the ratio of the Gross intake ratio(%) of Moldova in 2005 to that in 2010?
Keep it short and to the point. 0.93. What is the ratio of the Gross intake ratio(%) in Central Europe in 2005 to that in 2011?
Your answer should be very brief. 0.98. What is the ratio of the Gross intake ratio(%) of Upper middle income in 2005 to that in 2011?
Give a very brief answer. 1.01. What is the ratio of the Gross intake ratio(%) in Moldova in 2005 to that in 2011?
Offer a very short reply. 0.93. What is the ratio of the Gross intake ratio(%) of Sri Lanka in 2005 to that in 2011?
Give a very brief answer. 1.01. What is the ratio of the Gross intake ratio(%) in Central Europe in 2006 to that in 2007?
Give a very brief answer. 0.98. What is the ratio of the Gross intake ratio(%) of Moldova in 2006 to that in 2007?
Ensure brevity in your answer.  1.02. What is the ratio of the Gross intake ratio(%) in Sri Lanka in 2006 to that in 2007?
Provide a short and direct response. 0.99. What is the ratio of the Gross intake ratio(%) of Moldova in 2006 to that in 2010?
Make the answer very short. 1.01. What is the ratio of the Gross intake ratio(%) in Sri Lanka in 2006 to that in 2010?
Ensure brevity in your answer.  1.01. What is the ratio of the Gross intake ratio(%) in Central Europe in 2006 to that in 2011?
Make the answer very short. 0.99. What is the ratio of the Gross intake ratio(%) in Moldova in 2006 to that in 2011?
Keep it short and to the point. 1.01. What is the ratio of the Gross intake ratio(%) in Sri Lanka in 2006 to that in 2011?
Ensure brevity in your answer.  1.02. What is the ratio of the Gross intake ratio(%) in Central Europe in 2007 to that in 2010?
Give a very brief answer. 1.01. What is the ratio of the Gross intake ratio(%) in Upper middle income in 2007 to that in 2010?
Offer a terse response. 1.04. What is the ratio of the Gross intake ratio(%) in Moldova in 2007 to that in 2010?
Give a very brief answer. 0.99. What is the ratio of the Gross intake ratio(%) in Sri Lanka in 2007 to that in 2010?
Ensure brevity in your answer.  1.02. What is the ratio of the Gross intake ratio(%) of Upper middle income in 2007 to that in 2011?
Make the answer very short. 1.04. What is the ratio of the Gross intake ratio(%) in Moldova in 2007 to that in 2011?
Provide a succinct answer. 0.99. What is the ratio of the Gross intake ratio(%) of Sri Lanka in 2007 to that in 2011?
Keep it short and to the point. 1.03. What is the ratio of the Gross intake ratio(%) of Sri Lanka in 2010 to that in 2011?
Offer a very short reply. 1.01. What is the difference between the highest and the second highest Gross intake ratio(%) of Central Europe?
Your answer should be very brief. 0.78. What is the difference between the highest and the second highest Gross intake ratio(%) of Upper middle income?
Give a very brief answer. 2.2. What is the difference between the highest and the second highest Gross intake ratio(%) of Moldova?
Keep it short and to the point. 3.16. What is the difference between the highest and the second highest Gross intake ratio(%) of Sri Lanka?
Your answer should be very brief. 0.58. What is the difference between the highest and the lowest Gross intake ratio(%) in Central Europe?
Offer a very short reply. 2.56. What is the difference between the highest and the lowest Gross intake ratio(%) of Upper middle income?
Ensure brevity in your answer.  4.46. What is the difference between the highest and the lowest Gross intake ratio(%) in Moldova?
Give a very brief answer. 10.31. What is the difference between the highest and the lowest Gross intake ratio(%) of Sri Lanka?
Keep it short and to the point. 2.52. 